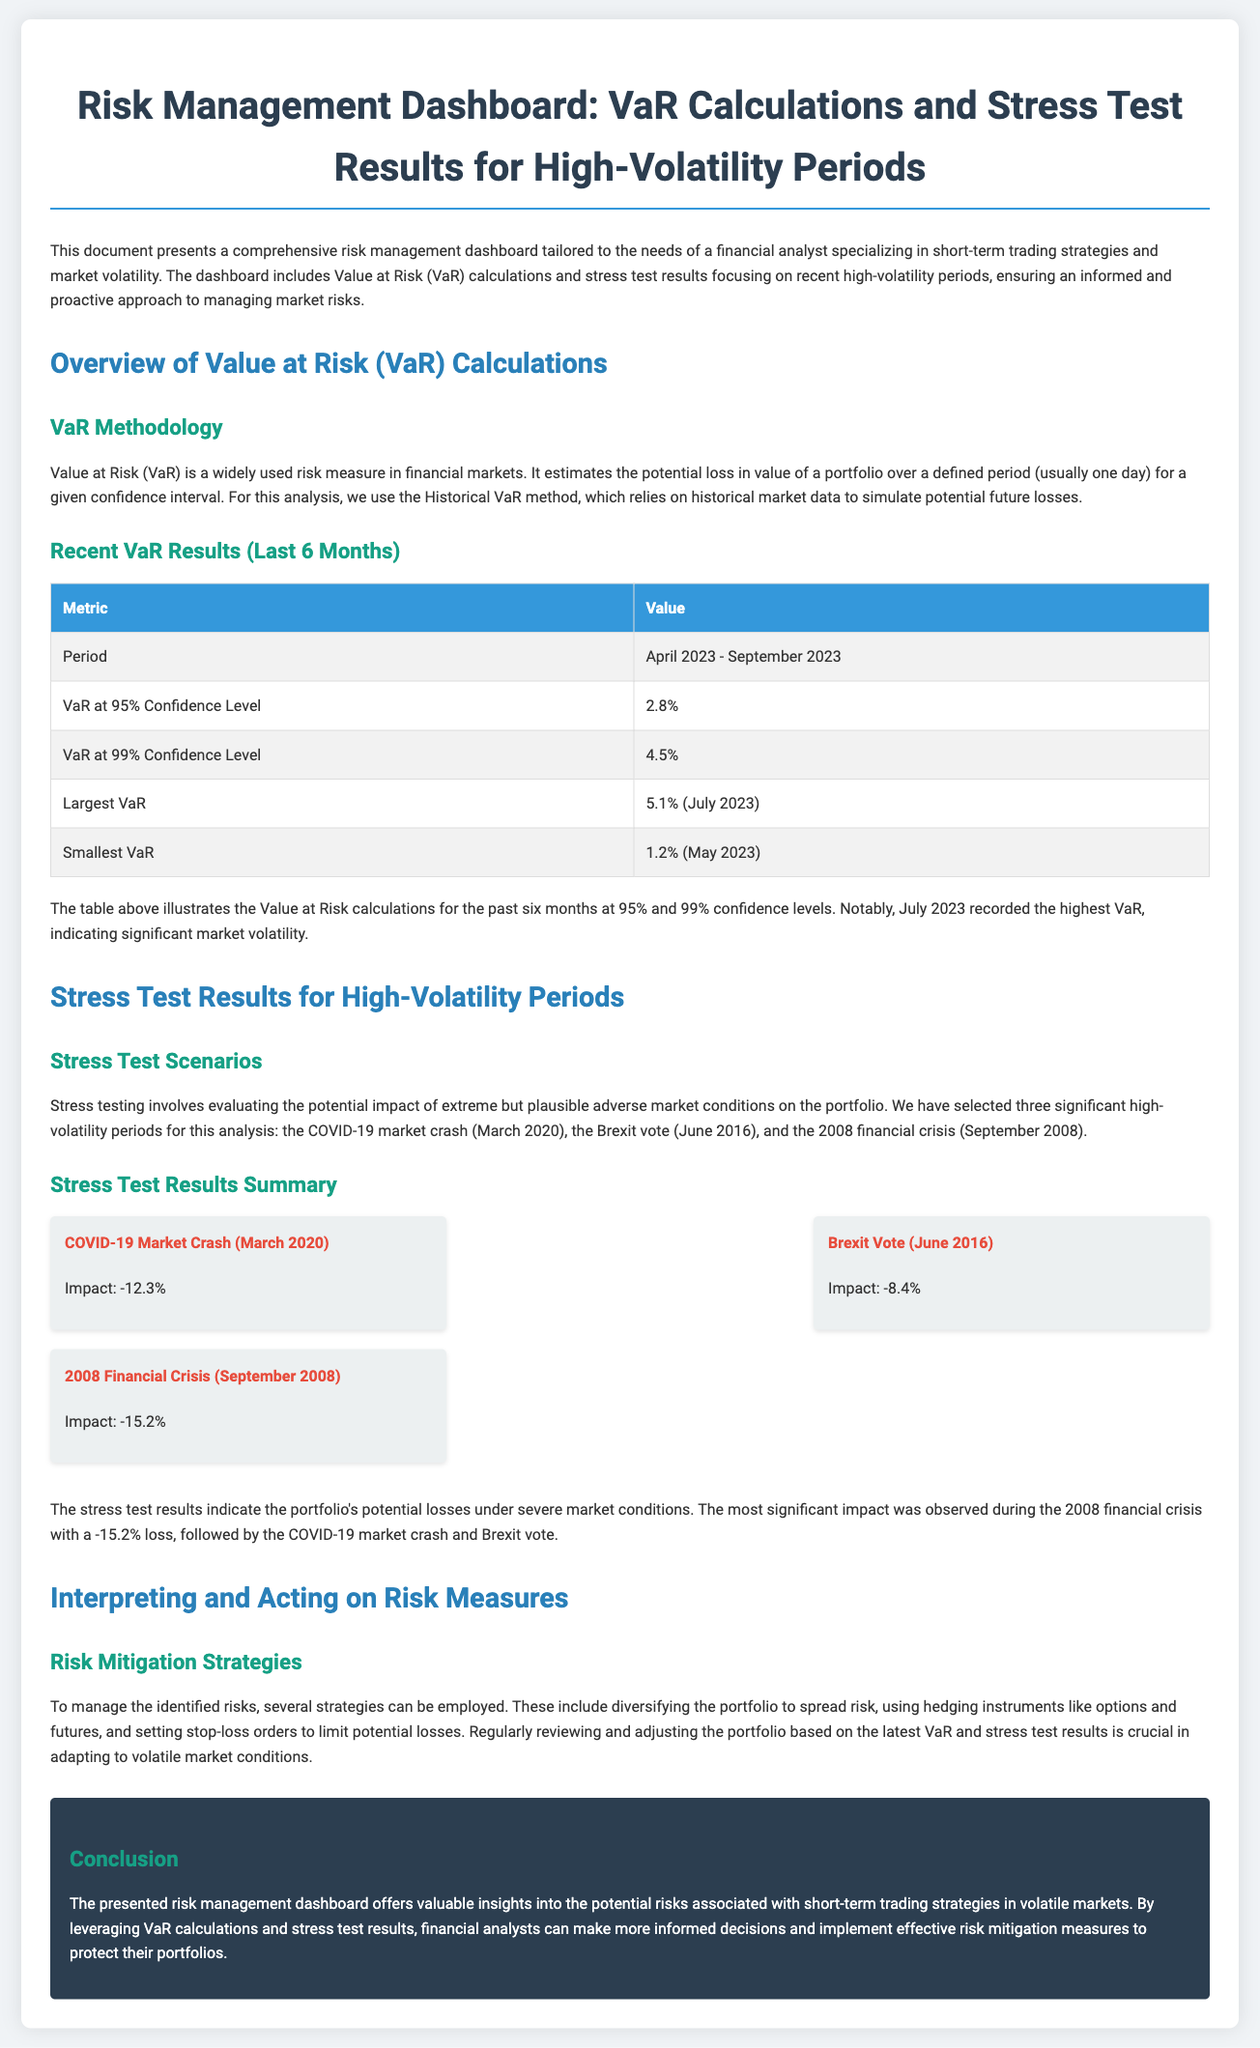What is the period covered in the VaR analysis? The document specifies the period as that during which the VaR calculations were made, which is April 2023 to September 2023.
Answer: April 2023 - September 2023 What is the VaR at a 95% confidence level? The VaR at a 95% confidence level is given directly in the document under the relevant section.
Answer: 2.8% What was the largest VaR recorded? The document notes the details about the largest VaR, including the value and the specific month it occurred.
Answer: 5.1% (July 2023) Which event resulted in the most significant loss during stress testing? By analyzing the stress test results, the document identifies the event with the highest impact on the portfolio.
Answer: 2008 Financial Crisis (September 2008) What was the impact of the Brexit vote during the stress test? The document summarizes the impacts of various stress test scenarios and lists the specific impact of the Brexit vote.
Answer: -8.4% How is Value at Risk (VaR) calculated according to the document? The methodology section discusses how the VaR is calculated based on historical market data.
Answer: Historical VaR method What risk mitigation strategies are suggested? The document outlines several strategies for managing the identified risks in the analysis.
Answer: Diversifying the portfolio, hedging instruments, stop-loss orders What confidence level was used for the VaR at 99%? The document specifies the value of VaR at the mentioned confidence level in the results section.
Answer: 4.5% What type of document is presented here? The title of the document indicates its nature and the information it intends to convey.
Answer: Risk Management Dashboard 